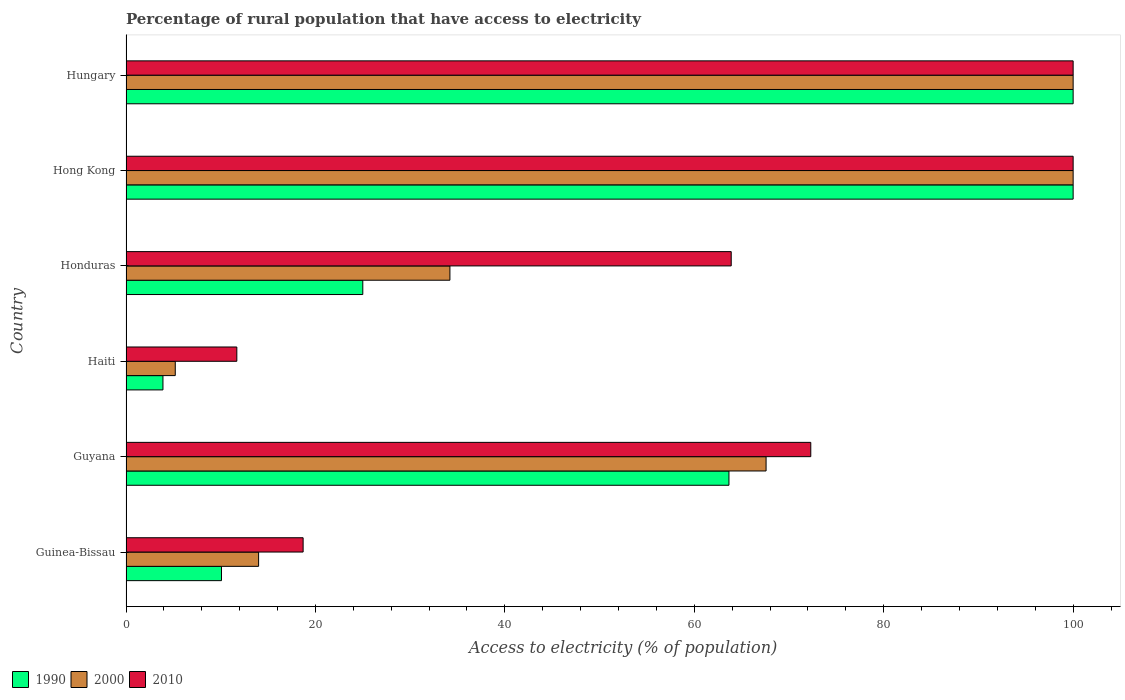How many different coloured bars are there?
Ensure brevity in your answer.  3. What is the label of the 6th group of bars from the top?
Ensure brevity in your answer.  Guinea-Bissau. What is the percentage of rural population that have access to electricity in 2010 in Guyana?
Provide a short and direct response. 72.3. Across all countries, what is the minimum percentage of rural population that have access to electricity in 2000?
Your answer should be compact. 5.2. In which country was the percentage of rural population that have access to electricity in 1990 maximum?
Keep it short and to the point. Hong Kong. In which country was the percentage of rural population that have access to electricity in 2010 minimum?
Offer a terse response. Haiti. What is the total percentage of rural population that have access to electricity in 2000 in the graph?
Make the answer very short. 320.98. What is the difference between the percentage of rural population that have access to electricity in 1990 in Guinea-Bissau and that in Guyana?
Ensure brevity in your answer.  -53.58. What is the average percentage of rural population that have access to electricity in 1990 per country?
Make the answer very short. 50.44. In how many countries, is the percentage of rural population that have access to electricity in 2010 greater than 68 %?
Make the answer very short. 3. What is the ratio of the percentage of rural population that have access to electricity in 2000 in Hong Kong to that in Hungary?
Provide a short and direct response. 1. Is the percentage of rural population that have access to electricity in 2000 in Guyana less than that in Haiti?
Ensure brevity in your answer.  No. Is the difference between the percentage of rural population that have access to electricity in 1990 in Hong Kong and Hungary greater than the difference between the percentage of rural population that have access to electricity in 2010 in Hong Kong and Hungary?
Your answer should be compact. No. What is the difference between the highest and the lowest percentage of rural population that have access to electricity in 1990?
Ensure brevity in your answer.  96.1. Is the sum of the percentage of rural population that have access to electricity in 2000 in Haiti and Hong Kong greater than the maximum percentage of rural population that have access to electricity in 2010 across all countries?
Provide a short and direct response. Yes. How many bars are there?
Provide a short and direct response. 18. How many countries are there in the graph?
Give a very brief answer. 6. What is the difference between two consecutive major ticks on the X-axis?
Keep it short and to the point. 20. Does the graph contain grids?
Your answer should be very brief. No. How many legend labels are there?
Give a very brief answer. 3. How are the legend labels stacked?
Offer a very short reply. Horizontal. What is the title of the graph?
Your response must be concise. Percentage of rural population that have access to electricity. Does "1986" appear as one of the legend labels in the graph?
Your answer should be very brief. No. What is the label or title of the X-axis?
Provide a succinct answer. Access to electricity (% of population). What is the label or title of the Y-axis?
Ensure brevity in your answer.  Country. What is the Access to electricity (% of population) of 1990 in Guinea-Bissau?
Your answer should be compact. 10.08. What is the Access to electricity (% of population) of 2000 in Guinea-Bissau?
Keep it short and to the point. 14. What is the Access to electricity (% of population) in 2010 in Guinea-Bissau?
Your response must be concise. 18.7. What is the Access to electricity (% of population) of 1990 in Guyana?
Keep it short and to the point. 63.66. What is the Access to electricity (% of population) of 2000 in Guyana?
Your answer should be compact. 67.58. What is the Access to electricity (% of population) of 2010 in Guyana?
Offer a very short reply. 72.3. What is the Access to electricity (% of population) in 2000 in Haiti?
Your response must be concise. 5.2. What is the Access to electricity (% of population) of 2000 in Honduras?
Offer a terse response. 34.2. What is the Access to electricity (% of population) of 2010 in Honduras?
Provide a short and direct response. 63.9. What is the Access to electricity (% of population) in 1990 in Hong Kong?
Offer a very short reply. 100. What is the Access to electricity (% of population) in 2000 in Hong Kong?
Provide a short and direct response. 100. What is the Access to electricity (% of population) of 2010 in Hong Kong?
Ensure brevity in your answer.  100. What is the Access to electricity (% of population) of 1990 in Hungary?
Give a very brief answer. 100. Across all countries, what is the maximum Access to electricity (% of population) of 1990?
Ensure brevity in your answer.  100. Across all countries, what is the maximum Access to electricity (% of population) of 2000?
Keep it short and to the point. 100. Across all countries, what is the maximum Access to electricity (% of population) in 2010?
Make the answer very short. 100. Across all countries, what is the minimum Access to electricity (% of population) in 2000?
Give a very brief answer. 5.2. Across all countries, what is the minimum Access to electricity (% of population) of 2010?
Your response must be concise. 11.7. What is the total Access to electricity (% of population) of 1990 in the graph?
Keep it short and to the point. 302.64. What is the total Access to electricity (% of population) in 2000 in the graph?
Provide a short and direct response. 320.98. What is the total Access to electricity (% of population) of 2010 in the graph?
Provide a short and direct response. 366.6. What is the difference between the Access to electricity (% of population) in 1990 in Guinea-Bissau and that in Guyana?
Keep it short and to the point. -53.58. What is the difference between the Access to electricity (% of population) in 2000 in Guinea-Bissau and that in Guyana?
Ensure brevity in your answer.  -53.58. What is the difference between the Access to electricity (% of population) of 2010 in Guinea-Bissau and that in Guyana?
Keep it short and to the point. -53.6. What is the difference between the Access to electricity (% of population) of 1990 in Guinea-Bissau and that in Haiti?
Offer a terse response. 6.18. What is the difference between the Access to electricity (% of population) of 2000 in Guinea-Bissau and that in Haiti?
Offer a terse response. 8.8. What is the difference between the Access to electricity (% of population) of 1990 in Guinea-Bissau and that in Honduras?
Provide a succinct answer. -14.92. What is the difference between the Access to electricity (% of population) of 2000 in Guinea-Bissau and that in Honduras?
Your response must be concise. -20.2. What is the difference between the Access to electricity (% of population) of 2010 in Guinea-Bissau and that in Honduras?
Your answer should be compact. -45.2. What is the difference between the Access to electricity (% of population) in 1990 in Guinea-Bissau and that in Hong Kong?
Ensure brevity in your answer.  -89.92. What is the difference between the Access to electricity (% of population) of 2000 in Guinea-Bissau and that in Hong Kong?
Provide a short and direct response. -86. What is the difference between the Access to electricity (% of population) in 2010 in Guinea-Bissau and that in Hong Kong?
Give a very brief answer. -81.3. What is the difference between the Access to electricity (% of population) of 1990 in Guinea-Bissau and that in Hungary?
Your response must be concise. -89.92. What is the difference between the Access to electricity (% of population) in 2000 in Guinea-Bissau and that in Hungary?
Ensure brevity in your answer.  -86. What is the difference between the Access to electricity (% of population) of 2010 in Guinea-Bissau and that in Hungary?
Provide a succinct answer. -81.3. What is the difference between the Access to electricity (% of population) in 1990 in Guyana and that in Haiti?
Give a very brief answer. 59.76. What is the difference between the Access to electricity (% of population) in 2000 in Guyana and that in Haiti?
Offer a terse response. 62.38. What is the difference between the Access to electricity (% of population) in 2010 in Guyana and that in Haiti?
Ensure brevity in your answer.  60.6. What is the difference between the Access to electricity (% of population) in 1990 in Guyana and that in Honduras?
Keep it short and to the point. 38.66. What is the difference between the Access to electricity (% of population) in 2000 in Guyana and that in Honduras?
Make the answer very short. 33.38. What is the difference between the Access to electricity (% of population) in 2010 in Guyana and that in Honduras?
Offer a terse response. 8.4. What is the difference between the Access to electricity (% of population) of 1990 in Guyana and that in Hong Kong?
Ensure brevity in your answer.  -36.34. What is the difference between the Access to electricity (% of population) of 2000 in Guyana and that in Hong Kong?
Give a very brief answer. -32.42. What is the difference between the Access to electricity (% of population) in 2010 in Guyana and that in Hong Kong?
Give a very brief answer. -27.7. What is the difference between the Access to electricity (% of population) of 1990 in Guyana and that in Hungary?
Provide a succinct answer. -36.34. What is the difference between the Access to electricity (% of population) of 2000 in Guyana and that in Hungary?
Give a very brief answer. -32.42. What is the difference between the Access to electricity (% of population) of 2010 in Guyana and that in Hungary?
Provide a succinct answer. -27.7. What is the difference between the Access to electricity (% of population) of 1990 in Haiti and that in Honduras?
Ensure brevity in your answer.  -21.1. What is the difference between the Access to electricity (% of population) of 2010 in Haiti and that in Honduras?
Offer a very short reply. -52.2. What is the difference between the Access to electricity (% of population) in 1990 in Haiti and that in Hong Kong?
Provide a short and direct response. -96.1. What is the difference between the Access to electricity (% of population) in 2000 in Haiti and that in Hong Kong?
Ensure brevity in your answer.  -94.8. What is the difference between the Access to electricity (% of population) in 2010 in Haiti and that in Hong Kong?
Give a very brief answer. -88.3. What is the difference between the Access to electricity (% of population) in 1990 in Haiti and that in Hungary?
Keep it short and to the point. -96.1. What is the difference between the Access to electricity (% of population) in 2000 in Haiti and that in Hungary?
Your answer should be compact. -94.8. What is the difference between the Access to electricity (% of population) in 2010 in Haiti and that in Hungary?
Provide a succinct answer. -88.3. What is the difference between the Access to electricity (% of population) in 1990 in Honduras and that in Hong Kong?
Give a very brief answer. -75. What is the difference between the Access to electricity (% of population) in 2000 in Honduras and that in Hong Kong?
Provide a succinct answer. -65.8. What is the difference between the Access to electricity (% of population) of 2010 in Honduras and that in Hong Kong?
Keep it short and to the point. -36.1. What is the difference between the Access to electricity (% of population) in 1990 in Honduras and that in Hungary?
Offer a very short reply. -75. What is the difference between the Access to electricity (% of population) of 2000 in Honduras and that in Hungary?
Ensure brevity in your answer.  -65.8. What is the difference between the Access to electricity (% of population) in 2010 in Honduras and that in Hungary?
Ensure brevity in your answer.  -36.1. What is the difference between the Access to electricity (% of population) in 1990 in Guinea-Bissau and the Access to electricity (% of population) in 2000 in Guyana?
Make the answer very short. -57.5. What is the difference between the Access to electricity (% of population) of 1990 in Guinea-Bissau and the Access to electricity (% of population) of 2010 in Guyana?
Your answer should be very brief. -62.22. What is the difference between the Access to electricity (% of population) of 2000 in Guinea-Bissau and the Access to electricity (% of population) of 2010 in Guyana?
Make the answer very short. -58.3. What is the difference between the Access to electricity (% of population) in 1990 in Guinea-Bissau and the Access to electricity (% of population) in 2000 in Haiti?
Ensure brevity in your answer.  4.88. What is the difference between the Access to electricity (% of population) of 1990 in Guinea-Bissau and the Access to electricity (% of population) of 2010 in Haiti?
Offer a very short reply. -1.62. What is the difference between the Access to electricity (% of population) in 1990 in Guinea-Bissau and the Access to electricity (% of population) in 2000 in Honduras?
Offer a very short reply. -24.12. What is the difference between the Access to electricity (% of population) in 1990 in Guinea-Bissau and the Access to electricity (% of population) in 2010 in Honduras?
Make the answer very short. -53.82. What is the difference between the Access to electricity (% of population) in 2000 in Guinea-Bissau and the Access to electricity (% of population) in 2010 in Honduras?
Your answer should be compact. -49.9. What is the difference between the Access to electricity (% of population) in 1990 in Guinea-Bissau and the Access to electricity (% of population) in 2000 in Hong Kong?
Offer a very short reply. -89.92. What is the difference between the Access to electricity (% of population) of 1990 in Guinea-Bissau and the Access to electricity (% of population) of 2010 in Hong Kong?
Offer a very short reply. -89.92. What is the difference between the Access to electricity (% of population) of 2000 in Guinea-Bissau and the Access to electricity (% of population) of 2010 in Hong Kong?
Your answer should be compact. -86. What is the difference between the Access to electricity (% of population) in 1990 in Guinea-Bissau and the Access to electricity (% of population) in 2000 in Hungary?
Give a very brief answer. -89.92. What is the difference between the Access to electricity (% of population) of 1990 in Guinea-Bissau and the Access to electricity (% of population) of 2010 in Hungary?
Give a very brief answer. -89.92. What is the difference between the Access to electricity (% of population) of 2000 in Guinea-Bissau and the Access to electricity (% of population) of 2010 in Hungary?
Offer a very short reply. -86. What is the difference between the Access to electricity (% of population) of 1990 in Guyana and the Access to electricity (% of population) of 2000 in Haiti?
Your response must be concise. 58.46. What is the difference between the Access to electricity (% of population) of 1990 in Guyana and the Access to electricity (% of population) of 2010 in Haiti?
Your response must be concise. 51.96. What is the difference between the Access to electricity (% of population) of 2000 in Guyana and the Access to electricity (% of population) of 2010 in Haiti?
Keep it short and to the point. 55.88. What is the difference between the Access to electricity (% of population) of 1990 in Guyana and the Access to electricity (% of population) of 2000 in Honduras?
Offer a very short reply. 29.46. What is the difference between the Access to electricity (% of population) in 1990 in Guyana and the Access to electricity (% of population) in 2010 in Honduras?
Offer a very short reply. -0.24. What is the difference between the Access to electricity (% of population) in 2000 in Guyana and the Access to electricity (% of population) in 2010 in Honduras?
Offer a terse response. 3.68. What is the difference between the Access to electricity (% of population) in 1990 in Guyana and the Access to electricity (% of population) in 2000 in Hong Kong?
Your answer should be compact. -36.34. What is the difference between the Access to electricity (% of population) in 1990 in Guyana and the Access to electricity (% of population) in 2010 in Hong Kong?
Your answer should be compact. -36.34. What is the difference between the Access to electricity (% of population) in 2000 in Guyana and the Access to electricity (% of population) in 2010 in Hong Kong?
Offer a terse response. -32.42. What is the difference between the Access to electricity (% of population) in 1990 in Guyana and the Access to electricity (% of population) in 2000 in Hungary?
Provide a short and direct response. -36.34. What is the difference between the Access to electricity (% of population) of 1990 in Guyana and the Access to electricity (% of population) of 2010 in Hungary?
Provide a succinct answer. -36.34. What is the difference between the Access to electricity (% of population) in 2000 in Guyana and the Access to electricity (% of population) in 2010 in Hungary?
Make the answer very short. -32.42. What is the difference between the Access to electricity (% of population) in 1990 in Haiti and the Access to electricity (% of population) in 2000 in Honduras?
Offer a very short reply. -30.3. What is the difference between the Access to electricity (% of population) in 1990 in Haiti and the Access to electricity (% of population) in 2010 in Honduras?
Give a very brief answer. -60. What is the difference between the Access to electricity (% of population) of 2000 in Haiti and the Access to electricity (% of population) of 2010 in Honduras?
Provide a succinct answer. -58.7. What is the difference between the Access to electricity (% of population) of 1990 in Haiti and the Access to electricity (% of population) of 2000 in Hong Kong?
Offer a very short reply. -96.1. What is the difference between the Access to electricity (% of population) of 1990 in Haiti and the Access to electricity (% of population) of 2010 in Hong Kong?
Make the answer very short. -96.1. What is the difference between the Access to electricity (% of population) in 2000 in Haiti and the Access to electricity (% of population) in 2010 in Hong Kong?
Keep it short and to the point. -94.8. What is the difference between the Access to electricity (% of population) in 1990 in Haiti and the Access to electricity (% of population) in 2000 in Hungary?
Your answer should be very brief. -96.1. What is the difference between the Access to electricity (% of population) in 1990 in Haiti and the Access to electricity (% of population) in 2010 in Hungary?
Give a very brief answer. -96.1. What is the difference between the Access to electricity (% of population) of 2000 in Haiti and the Access to electricity (% of population) of 2010 in Hungary?
Ensure brevity in your answer.  -94.8. What is the difference between the Access to electricity (% of population) in 1990 in Honduras and the Access to electricity (% of population) in 2000 in Hong Kong?
Offer a terse response. -75. What is the difference between the Access to electricity (% of population) of 1990 in Honduras and the Access to electricity (% of population) of 2010 in Hong Kong?
Provide a short and direct response. -75. What is the difference between the Access to electricity (% of population) of 2000 in Honduras and the Access to electricity (% of population) of 2010 in Hong Kong?
Offer a very short reply. -65.8. What is the difference between the Access to electricity (% of population) in 1990 in Honduras and the Access to electricity (% of population) in 2000 in Hungary?
Keep it short and to the point. -75. What is the difference between the Access to electricity (% of population) in 1990 in Honduras and the Access to electricity (% of population) in 2010 in Hungary?
Your answer should be compact. -75. What is the difference between the Access to electricity (% of population) of 2000 in Honduras and the Access to electricity (% of population) of 2010 in Hungary?
Your answer should be very brief. -65.8. What is the difference between the Access to electricity (% of population) in 1990 in Hong Kong and the Access to electricity (% of population) in 2010 in Hungary?
Your answer should be compact. 0. What is the difference between the Access to electricity (% of population) in 2000 in Hong Kong and the Access to electricity (% of population) in 2010 in Hungary?
Keep it short and to the point. 0. What is the average Access to electricity (% of population) of 1990 per country?
Offer a very short reply. 50.44. What is the average Access to electricity (% of population) of 2000 per country?
Offer a very short reply. 53.5. What is the average Access to electricity (% of population) of 2010 per country?
Your answer should be compact. 61.1. What is the difference between the Access to electricity (% of population) in 1990 and Access to electricity (% of population) in 2000 in Guinea-Bissau?
Ensure brevity in your answer.  -3.92. What is the difference between the Access to electricity (% of population) in 1990 and Access to electricity (% of population) in 2010 in Guinea-Bissau?
Keep it short and to the point. -8.62. What is the difference between the Access to electricity (% of population) of 1990 and Access to electricity (% of population) of 2000 in Guyana?
Make the answer very short. -3.92. What is the difference between the Access to electricity (% of population) in 1990 and Access to electricity (% of population) in 2010 in Guyana?
Make the answer very short. -8.64. What is the difference between the Access to electricity (% of population) of 2000 and Access to electricity (% of population) of 2010 in Guyana?
Offer a very short reply. -4.72. What is the difference between the Access to electricity (% of population) in 1990 and Access to electricity (% of population) in 2010 in Honduras?
Keep it short and to the point. -38.9. What is the difference between the Access to electricity (% of population) in 2000 and Access to electricity (% of population) in 2010 in Honduras?
Keep it short and to the point. -29.7. What is the difference between the Access to electricity (% of population) in 1990 and Access to electricity (% of population) in 2010 in Hong Kong?
Provide a succinct answer. 0. What is the difference between the Access to electricity (% of population) of 1990 and Access to electricity (% of population) of 2000 in Hungary?
Keep it short and to the point. 0. What is the ratio of the Access to electricity (% of population) in 1990 in Guinea-Bissau to that in Guyana?
Offer a terse response. 0.16. What is the ratio of the Access to electricity (% of population) of 2000 in Guinea-Bissau to that in Guyana?
Your answer should be compact. 0.21. What is the ratio of the Access to electricity (% of population) in 2010 in Guinea-Bissau to that in Guyana?
Keep it short and to the point. 0.26. What is the ratio of the Access to electricity (% of population) of 1990 in Guinea-Bissau to that in Haiti?
Your answer should be very brief. 2.58. What is the ratio of the Access to electricity (% of population) of 2000 in Guinea-Bissau to that in Haiti?
Provide a succinct answer. 2.69. What is the ratio of the Access to electricity (% of population) in 2010 in Guinea-Bissau to that in Haiti?
Provide a short and direct response. 1.6. What is the ratio of the Access to electricity (% of population) of 1990 in Guinea-Bissau to that in Honduras?
Provide a succinct answer. 0.4. What is the ratio of the Access to electricity (% of population) of 2000 in Guinea-Bissau to that in Honduras?
Provide a succinct answer. 0.41. What is the ratio of the Access to electricity (% of population) of 2010 in Guinea-Bissau to that in Honduras?
Offer a terse response. 0.29. What is the ratio of the Access to electricity (% of population) in 1990 in Guinea-Bissau to that in Hong Kong?
Ensure brevity in your answer.  0.1. What is the ratio of the Access to electricity (% of population) of 2000 in Guinea-Bissau to that in Hong Kong?
Offer a terse response. 0.14. What is the ratio of the Access to electricity (% of population) of 2010 in Guinea-Bissau to that in Hong Kong?
Ensure brevity in your answer.  0.19. What is the ratio of the Access to electricity (% of population) of 1990 in Guinea-Bissau to that in Hungary?
Offer a terse response. 0.1. What is the ratio of the Access to electricity (% of population) of 2000 in Guinea-Bissau to that in Hungary?
Provide a short and direct response. 0.14. What is the ratio of the Access to electricity (% of population) in 2010 in Guinea-Bissau to that in Hungary?
Provide a short and direct response. 0.19. What is the ratio of the Access to electricity (% of population) in 1990 in Guyana to that in Haiti?
Your response must be concise. 16.32. What is the ratio of the Access to electricity (% of population) in 2000 in Guyana to that in Haiti?
Your answer should be compact. 13. What is the ratio of the Access to electricity (% of population) in 2010 in Guyana to that in Haiti?
Make the answer very short. 6.18. What is the ratio of the Access to electricity (% of population) in 1990 in Guyana to that in Honduras?
Provide a short and direct response. 2.55. What is the ratio of the Access to electricity (% of population) in 2000 in Guyana to that in Honduras?
Your response must be concise. 1.98. What is the ratio of the Access to electricity (% of population) of 2010 in Guyana to that in Honduras?
Offer a very short reply. 1.13. What is the ratio of the Access to electricity (% of population) of 1990 in Guyana to that in Hong Kong?
Your answer should be compact. 0.64. What is the ratio of the Access to electricity (% of population) in 2000 in Guyana to that in Hong Kong?
Provide a succinct answer. 0.68. What is the ratio of the Access to electricity (% of population) in 2010 in Guyana to that in Hong Kong?
Your answer should be very brief. 0.72. What is the ratio of the Access to electricity (% of population) of 1990 in Guyana to that in Hungary?
Make the answer very short. 0.64. What is the ratio of the Access to electricity (% of population) in 2000 in Guyana to that in Hungary?
Offer a very short reply. 0.68. What is the ratio of the Access to electricity (% of population) of 2010 in Guyana to that in Hungary?
Keep it short and to the point. 0.72. What is the ratio of the Access to electricity (% of population) of 1990 in Haiti to that in Honduras?
Offer a terse response. 0.16. What is the ratio of the Access to electricity (% of population) in 2000 in Haiti to that in Honduras?
Offer a terse response. 0.15. What is the ratio of the Access to electricity (% of population) of 2010 in Haiti to that in Honduras?
Give a very brief answer. 0.18. What is the ratio of the Access to electricity (% of population) in 1990 in Haiti to that in Hong Kong?
Provide a short and direct response. 0.04. What is the ratio of the Access to electricity (% of population) of 2000 in Haiti to that in Hong Kong?
Provide a short and direct response. 0.05. What is the ratio of the Access to electricity (% of population) in 2010 in Haiti to that in Hong Kong?
Ensure brevity in your answer.  0.12. What is the ratio of the Access to electricity (% of population) of 1990 in Haiti to that in Hungary?
Offer a very short reply. 0.04. What is the ratio of the Access to electricity (% of population) of 2000 in Haiti to that in Hungary?
Your response must be concise. 0.05. What is the ratio of the Access to electricity (% of population) of 2010 in Haiti to that in Hungary?
Keep it short and to the point. 0.12. What is the ratio of the Access to electricity (% of population) of 2000 in Honduras to that in Hong Kong?
Your response must be concise. 0.34. What is the ratio of the Access to electricity (% of population) in 2010 in Honduras to that in Hong Kong?
Give a very brief answer. 0.64. What is the ratio of the Access to electricity (% of population) of 2000 in Honduras to that in Hungary?
Provide a short and direct response. 0.34. What is the ratio of the Access to electricity (% of population) in 2010 in Honduras to that in Hungary?
Keep it short and to the point. 0.64. What is the ratio of the Access to electricity (% of population) of 2000 in Hong Kong to that in Hungary?
Your answer should be compact. 1. What is the ratio of the Access to electricity (% of population) in 2010 in Hong Kong to that in Hungary?
Offer a very short reply. 1. What is the difference between the highest and the second highest Access to electricity (% of population) of 1990?
Provide a succinct answer. 0. What is the difference between the highest and the second highest Access to electricity (% of population) in 2000?
Ensure brevity in your answer.  0. What is the difference between the highest and the second highest Access to electricity (% of population) of 2010?
Your answer should be compact. 0. What is the difference between the highest and the lowest Access to electricity (% of population) of 1990?
Offer a terse response. 96.1. What is the difference between the highest and the lowest Access to electricity (% of population) of 2000?
Ensure brevity in your answer.  94.8. What is the difference between the highest and the lowest Access to electricity (% of population) of 2010?
Your answer should be compact. 88.3. 